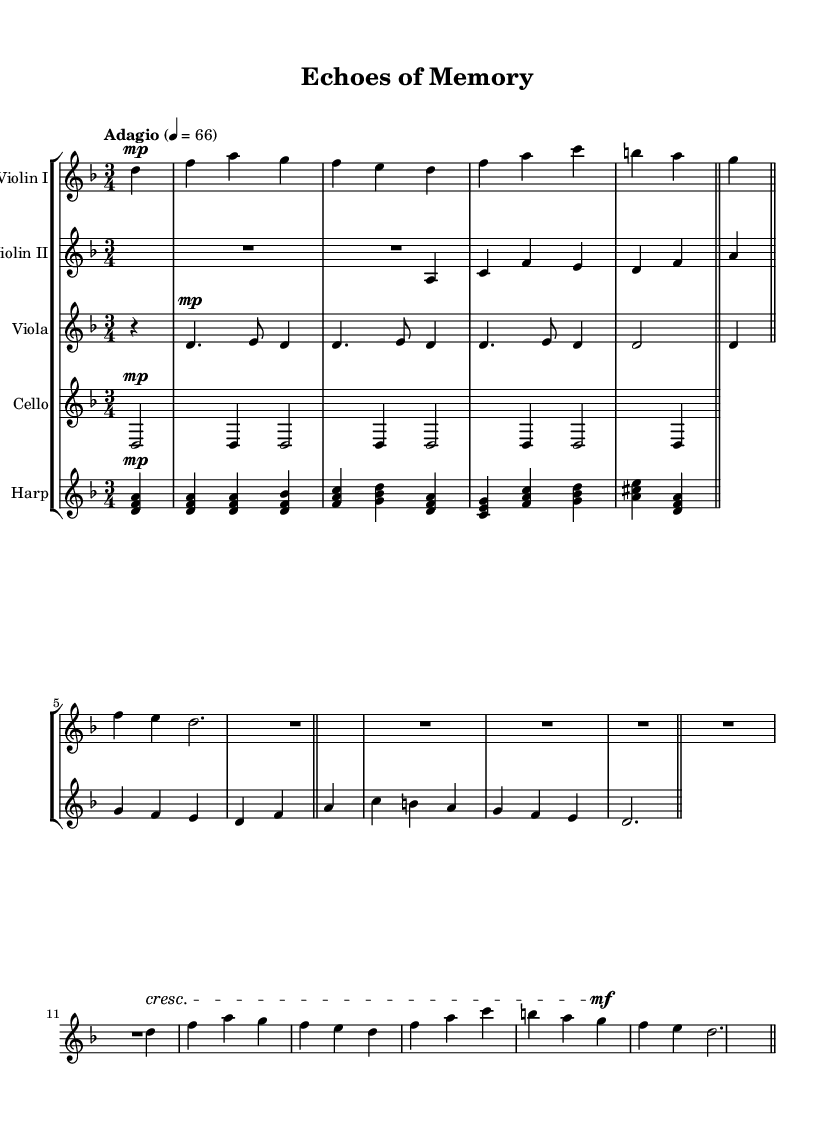What is the key signature of this music? The key signature is D minor, which includes one flat (B flat) indicating that the pitches should reflect this.
Answer: D minor What is the time signature? The time signature is 3/4, which means there are three beats per measure and the quarter note receives one beat.
Answer: 3/4 What is the tempo marking? The tempo marking is "Adagio," indicating that the piece should be played slowly. The metronome indication is 66 beats per minute.
Answer: Adagio How many measures are in the piece? By counting the number of measure lines in the score, we can see there are a total of 8 measures present.
Answer: 8 What instruments are used in this Symphony? The instruments used are Violin I, Violin II, Viola, Cello, and Harp, which form a traditional orchestral ensemble.
Answer: Violin I, Violin II, Viola, Cello, Harp What dynamic marking appears before the rest of the piece? The dynamic marking at the beginning is "mp," meaning mezzo-piano, indicating a moderately soft sound.
Answer: mezzo-piano How does the dynamic marking change throughout the piece? The dynamics vary, starting with "mp" and then include a "cresc" marking towards the end, suggesting a gradual increase in volume.
Answer: cresc 